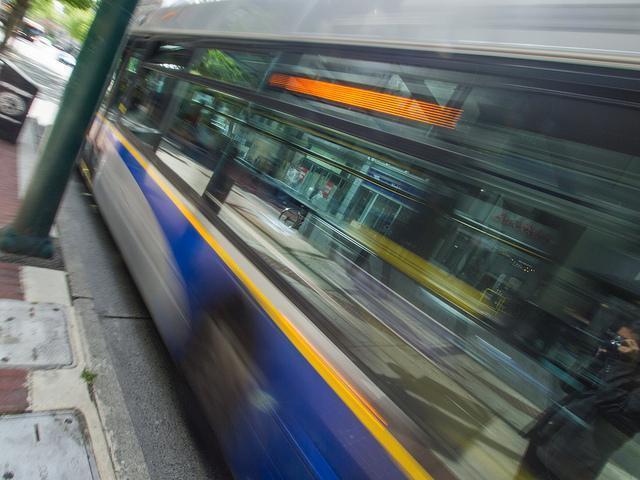How many train cars are in this photo?
Give a very brief answer. 0. 